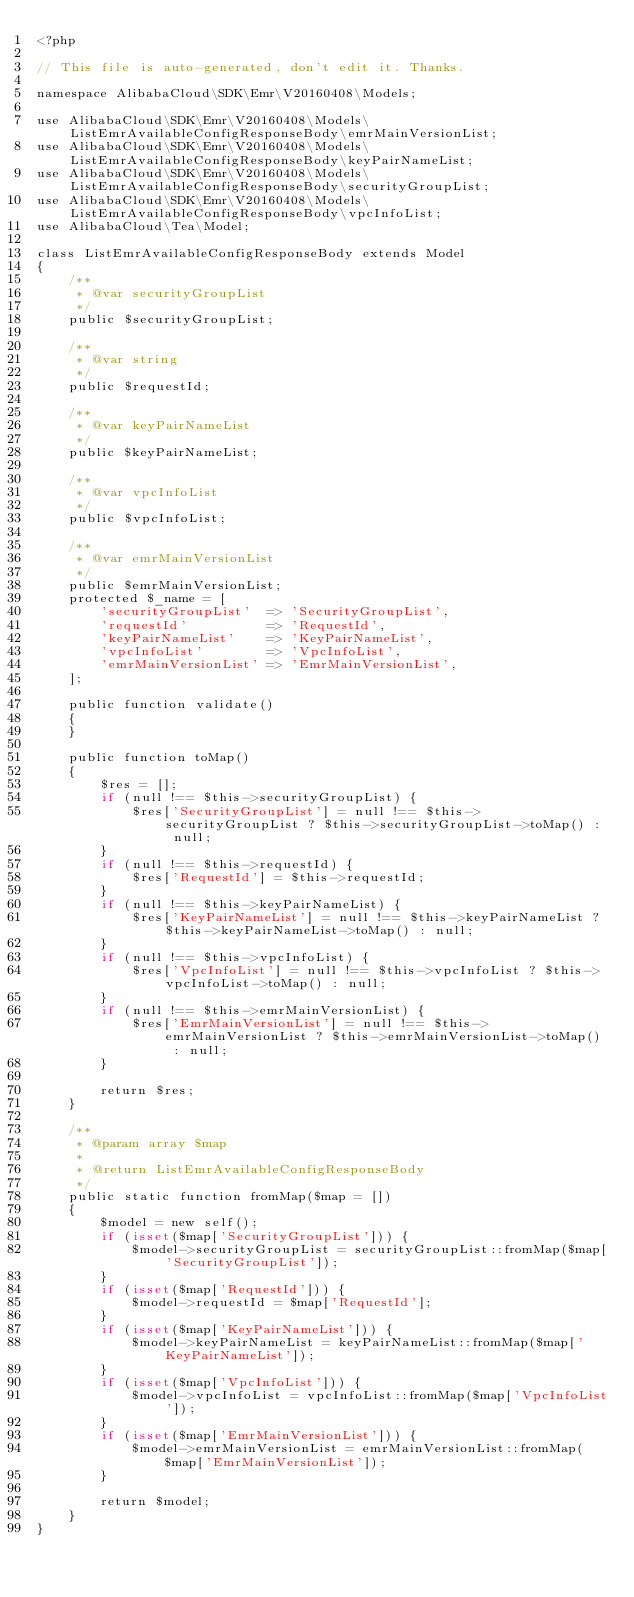<code> <loc_0><loc_0><loc_500><loc_500><_PHP_><?php

// This file is auto-generated, don't edit it. Thanks.

namespace AlibabaCloud\SDK\Emr\V20160408\Models;

use AlibabaCloud\SDK\Emr\V20160408\Models\ListEmrAvailableConfigResponseBody\emrMainVersionList;
use AlibabaCloud\SDK\Emr\V20160408\Models\ListEmrAvailableConfigResponseBody\keyPairNameList;
use AlibabaCloud\SDK\Emr\V20160408\Models\ListEmrAvailableConfigResponseBody\securityGroupList;
use AlibabaCloud\SDK\Emr\V20160408\Models\ListEmrAvailableConfigResponseBody\vpcInfoList;
use AlibabaCloud\Tea\Model;

class ListEmrAvailableConfigResponseBody extends Model
{
    /**
     * @var securityGroupList
     */
    public $securityGroupList;

    /**
     * @var string
     */
    public $requestId;

    /**
     * @var keyPairNameList
     */
    public $keyPairNameList;

    /**
     * @var vpcInfoList
     */
    public $vpcInfoList;

    /**
     * @var emrMainVersionList
     */
    public $emrMainVersionList;
    protected $_name = [
        'securityGroupList'  => 'SecurityGroupList',
        'requestId'          => 'RequestId',
        'keyPairNameList'    => 'KeyPairNameList',
        'vpcInfoList'        => 'VpcInfoList',
        'emrMainVersionList' => 'EmrMainVersionList',
    ];

    public function validate()
    {
    }

    public function toMap()
    {
        $res = [];
        if (null !== $this->securityGroupList) {
            $res['SecurityGroupList'] = null !== $this->securityGroupList ? $this->securityGroupList->toMap() : null;
        }
        if (null !== $this->requestId) {
            $res['RequestId'] = $this->requestId;
        }
        if (null !== $this->keyPairNameList) {
            $res['KeyPairNameList'] = null !== $this->keyPairNameList ? $this->keyPairNameList->toMap() : null;
        }
        if (null !== $this->vpcInfoList) {
            $res['VpcInfoList'] = null !== $this->vpcInfoList ? $this->vpcInfoList->toMap() : null;
        }
        if (null !== $this->emrMainVersionList) {
            $res['EmrMainVersionList'] = null !== $this->emrMainVersionList ? $this->emrMainVersionList->toMap() : null;
        }

        return $res;
    }

    /**
     * @param array $map
     *
     * @return ListEmrAvailableConfigResponseBody
     */
    public static function fromMap($map = [])
    {
        $model = new self();
        if (isset($map['SecurityGroupList'])) {
            $model->securityGroupList = securityGroupList::fromMap($map['SecurityGroupList']);
        }
        if (isset($map['RequestId'])) {
            $model->requestId = $map['RequestId'];
        }
        if (isset($map['KeyPairNameList'])) {
            $model->keyPairNameList = keyPairNameList::fromMap($map['KeyPairNameList']);
        }
        if (isset($map['VpcInfoList'])) {
            $model->vpcInfoList = vpcInfoList::fromMap($map['VpcInfoList']);
        }
        if (isset($map['EmrMainVersionList'])) {
            $model->emrMainVersionList = emrMainVersionList::fromMap($map['EmrMainVersionList']);
        }

        return $model;
    }
}
</code> 